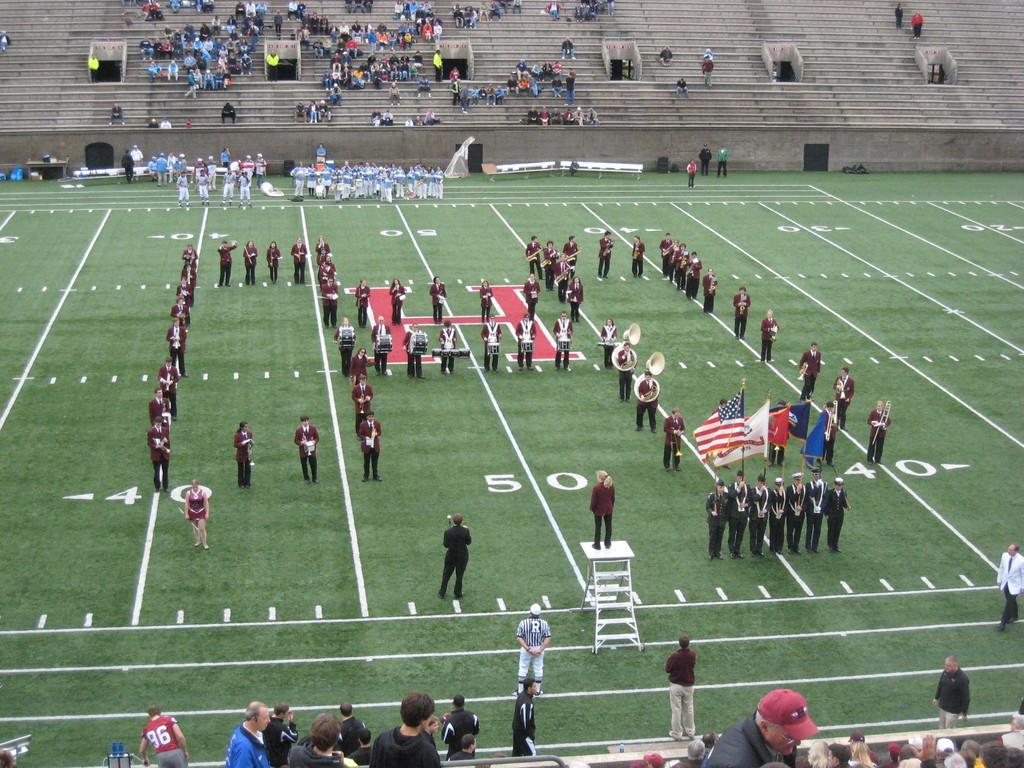Please provide a concise description of this image. In this image we can see a group of people on the ground in which some of them are holding flags and some of them are playing musical instruments, a person standing on a stand and a few marks on the ground, there we can also a few people sitting and standing in the stands. 